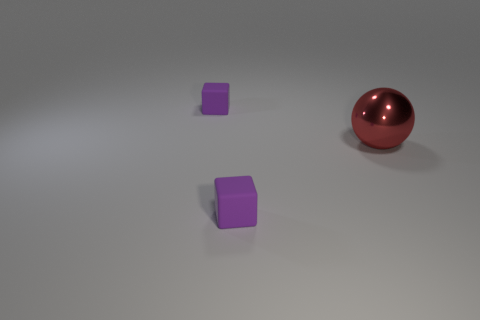Is there any other thing that has the same size as the red ball?
Your answer should be very brief. No. Is there anything else that has the same material as the big thing?
Your response must be concise. No. Is there a red ball?
Make the answer very short. Yes. What number of cylinders are either large objects or small rubber things?
Give a very brief answer. 0. What shape is the tiny purple object that is in front of the purple block to the left of the rubber cube in front of the shiny sphere?
Give a very brief answer. Cube. How many other red shiny spheres have the same size as the sphere?
Give a very brief answer. 0. Are there any red balls in front of the block in front of the red metallic thing?
Offer a very short reply. No. What number of objects are either tiny purple matte things or small balls?
Keep it short and to the point. 2. The tiny rubber object that is in front of the large object in front of the tiny purple rubber cube behind the big metallic sphere is what color?
Give a very brief answer. Purple. Is there anything else of the same color as the sphere?
Ensure brevity in your answer.  No. 